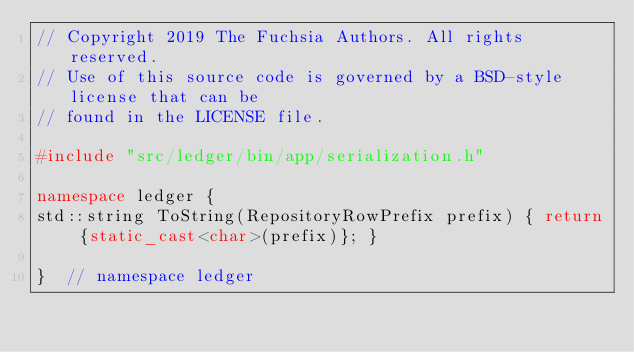Convert code to text. <code><loc_0><loc_0><loc_500><loc_500><_C++_>// Copyright 2019 The Fuchsia Authors. All rights reserved.
// Use of this source code is governed by a BSD-style license that can be
// found in the LICENSE file.

#include "src/ledger/bin/app/serialization.h"

namespace ledger {
std::string ToString(RepositoryRowPrefix prefix) { return {static_cast<char>(prefix)}; }

}  // namespace ledger
</code> 